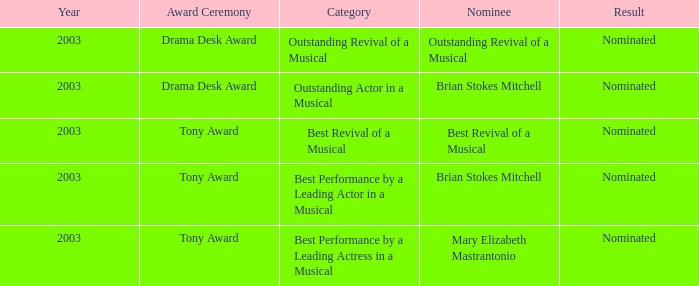What year was Mary Elizabeth Mastrantonio nominated? 2003.0. 